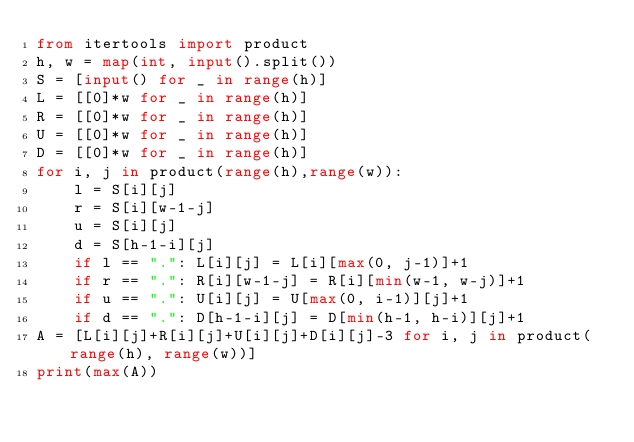<code> <loc_0><loc_0><loc_500><loc_500><_Python_>from itertools import product
h, w = map(int, input().split())
S = [input() for _ in range(h)]
L = [[0]*w for _ in range(h)]
R = [[0]*w for _ in range(h)]
U = [[0]*w for _ in range(h)]
D = [[0]*w for _ in range(h)]
for i, j in product(range(h),range(w)):
    l = S[i][j]
    r = S[i][w-1-j]
    u = S[i][j]
    d = S[h-1-i][j]
    if l == ".": L[i][j] = L[i][max(0, j-1)]+1
    if r == ".": R[i][w-1-j] = R[i][min(w-1, w-j)]+1
    if u == ".": U[i][j] = U[max(0, i-1)][j]+1
    if d == ".": D[h-1-i][j] = D[min(h-1, h-i)][j]+1
A = [L[i][j]+R[i][j]+U[i][j]+D[i][j]-3 for i, j in product(range(h), range(w))]
print(max(A))</code> 